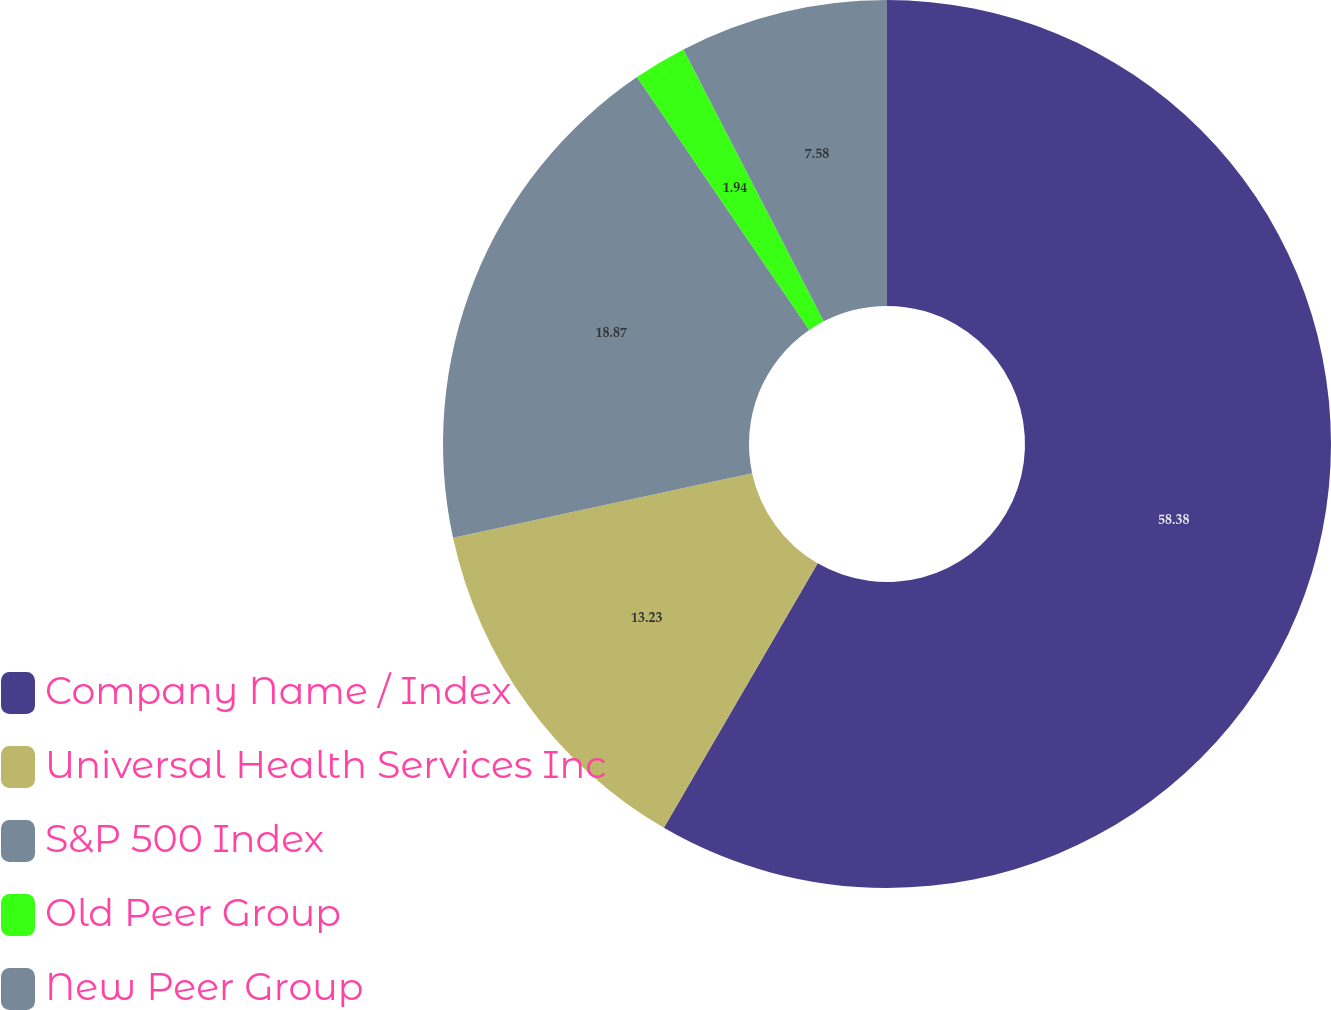Convert chart. <chart><loc_0><loc_0><loc_500><loc_500><pie_chart><fcel>Company Name / Index<fcel>Universal Health Services Inc<fcel>S&P 500 Index<fcel>Old Peer Group<fcel>New Peer Group<nl><fcel>58.38%<fcel>13.23%<fcel>18.87%<fcel>1.94%<fcel>7.58%<nl></chart> 